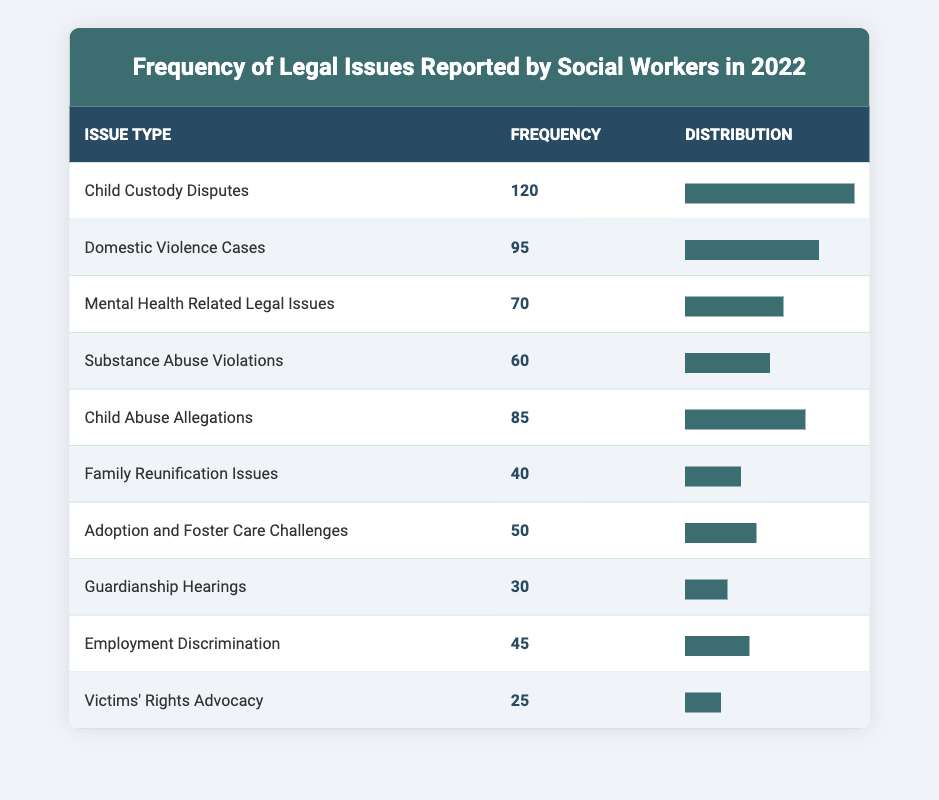What is the most reported legal issue by social workers in 2022? The table shows that the most reported legal issue is "Child Custody Disputes," which has a frequency of 120.
Answer: Child Custody Disputes How many legal issues had a frequency of 60 or more? By examining the frequencies in the table, we count the issues: Child Custody Disputes (120), Domestic Violence Cases (95), Mental Health Related Legal Issues (70), Child Abuse Allegations (85), and Substance Abuse Violations (60). This totals to 5 issues.
Answer: 5 What is the frequency of "Guardianship Hearings"? Looking at the table, "Guardianship Hearings" has a frequency of 30, which is directly stated.
Answer: 30 Is the frequency of "Victims' Rights Advocacy" greater than that of "Employment Discrimination"? We check the frequencies: Victims' Rights Advocacy has a frequency of 25, while Employment Discrimination has a frequency of 45. Since 25 is less than 45, the statement is false.
Answer: No What is the total frequency of all legal issues reported? We can sum the frequencies as follows: 120 + 95 + 70 + 60 + 85 + 40 + 50 + 30 + 45 + 25 = 750. The total frequency of all legal issues reported is 750.
Answer: 750 Which legal issue has a frequency closest to the average frequency of all the issues? First, calculate the average frequency: 750 total frequencies divided by 10 issues gives an average of 75. The issues closest to this average are Substance Abuse Violations (60) and Mental Health Related Legal Issues (70).
Answer: Substance Abuse Violations and Mental Health Related Legal Issues What is the difference in frequency between the highest and the lowest reported legal issue? The highest frequency is for Child Custody Disputes at 120, and the lowest is for Victims' Rights Advocacy at 25. The difference is calculated as 120 - 25 = 95.
Answer: 95 How many issues had frequencies less than 50? Looking through the table, we identify the frequencies: Family Reunification Issues (40), Guardianship Hearings (30), and Victims' Rights Advocacy (25). There are 3 issues with frequencies below 50.
Answer: 3 Which issue is reported least frequently? The table indicates that "Victims' Rights Advocacy" has the lowest frequency, which is 25.
Answer: Victims' Rights Advocacy 